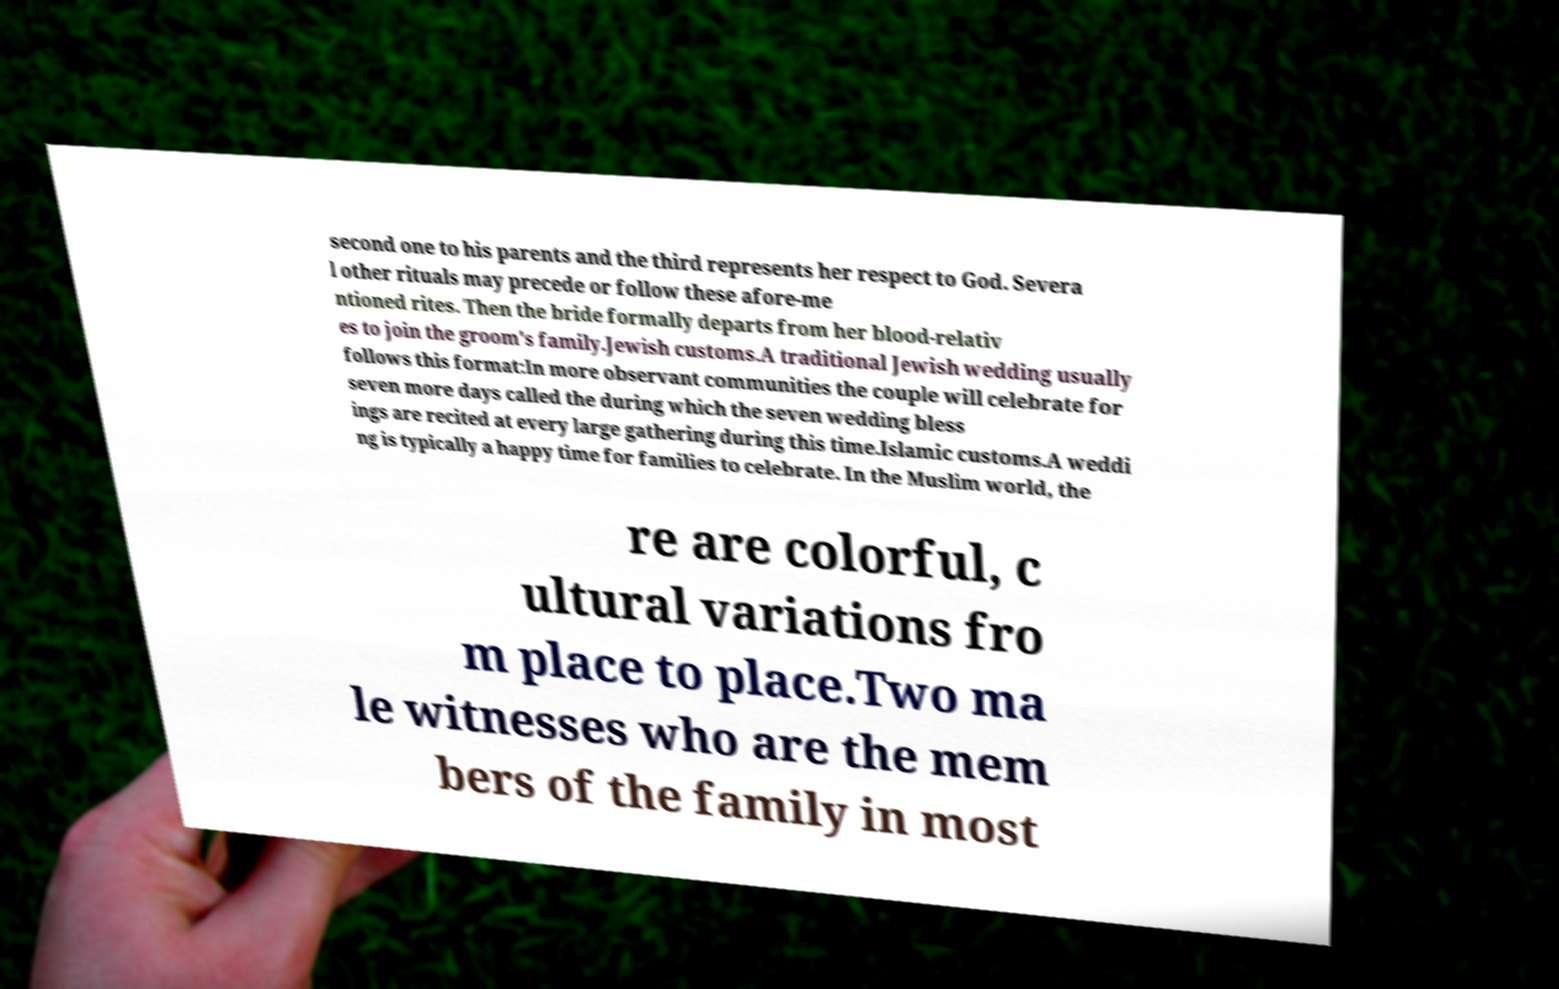What messages or text are displayed in this image? I need them in a readable, typed format. second one to his parents and the third represents her respect to God. Severa l other rituals may precede or follow these afore-me ntioned rites. Then the bride formally departs from her blood-relativ es to join the groom's family.Jewish customs.A traditional Jewish wedding usually follows this format:In more observant communities the couple will celebrate for seven more days called the during which the seven wedding bless ings are recited at every large gathering during this time.Islamic customs.A weddi ng is typically a happy time for families to celebrate. In the Muslim world, the re are colorful, c ultural variations fro m place to place.Two ma le witnesses who are the mem bers of the family in most 